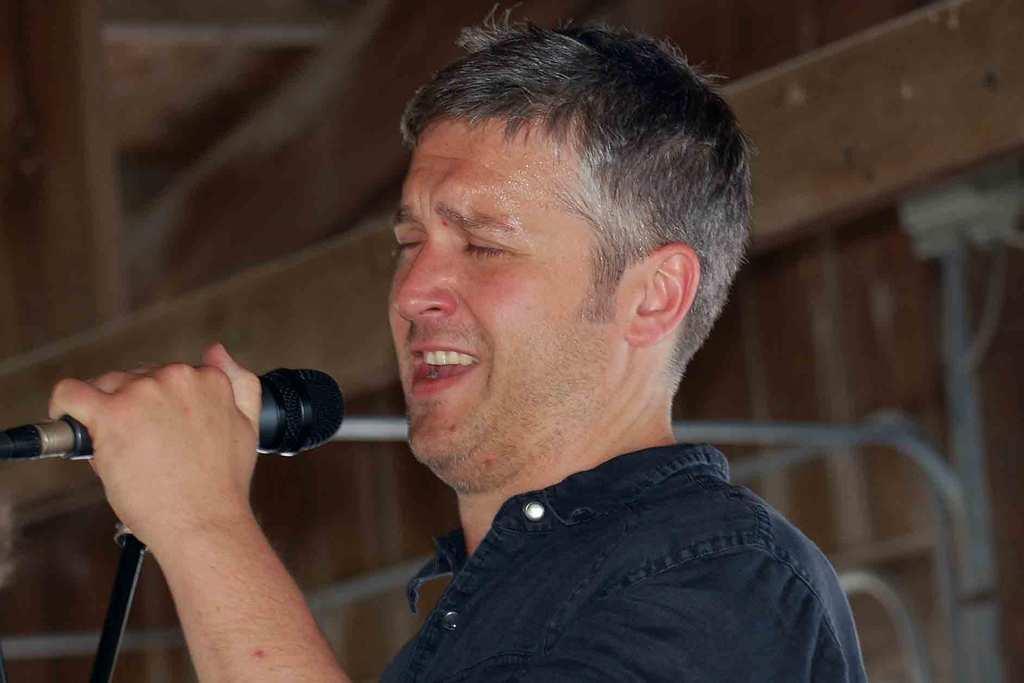Describe this image in one or two sentences. In the middle of the image a man is holding microphone and singing. 